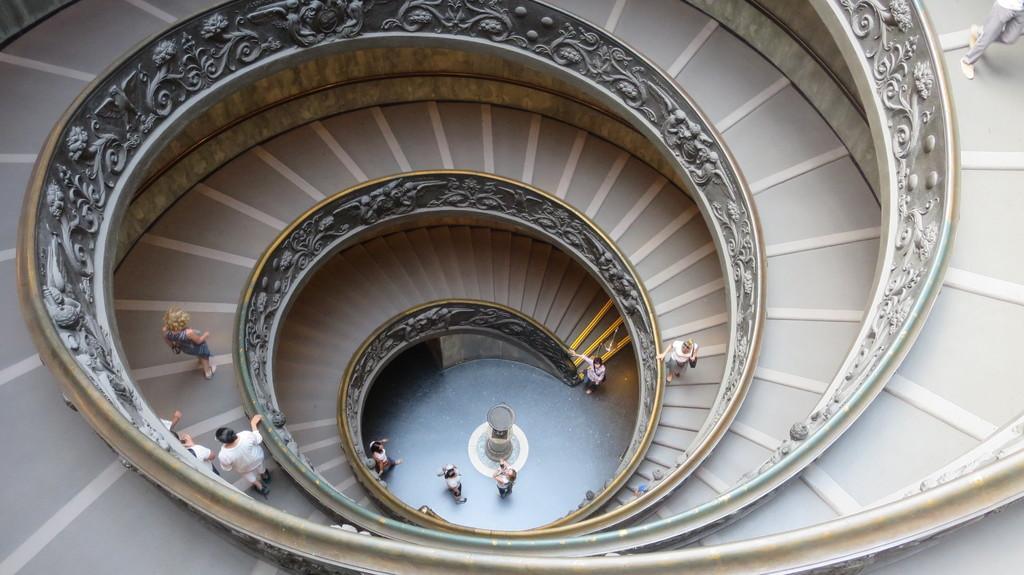In one or two sentences, can you explain what this image depicts? In this image we can see an interior of the building. There are staircases in the image. There are many people in the image. There is an object on the floor. 